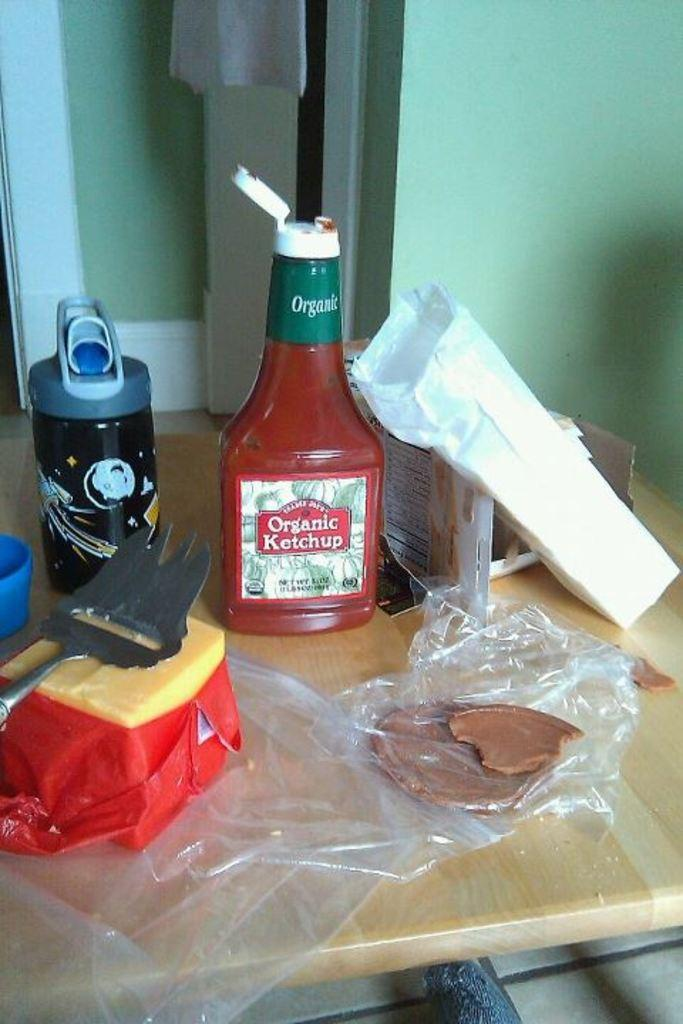<image>
Render a clear and concise summary of the photo. A bottle or organic ketchup sits open on a table along with some other food. 